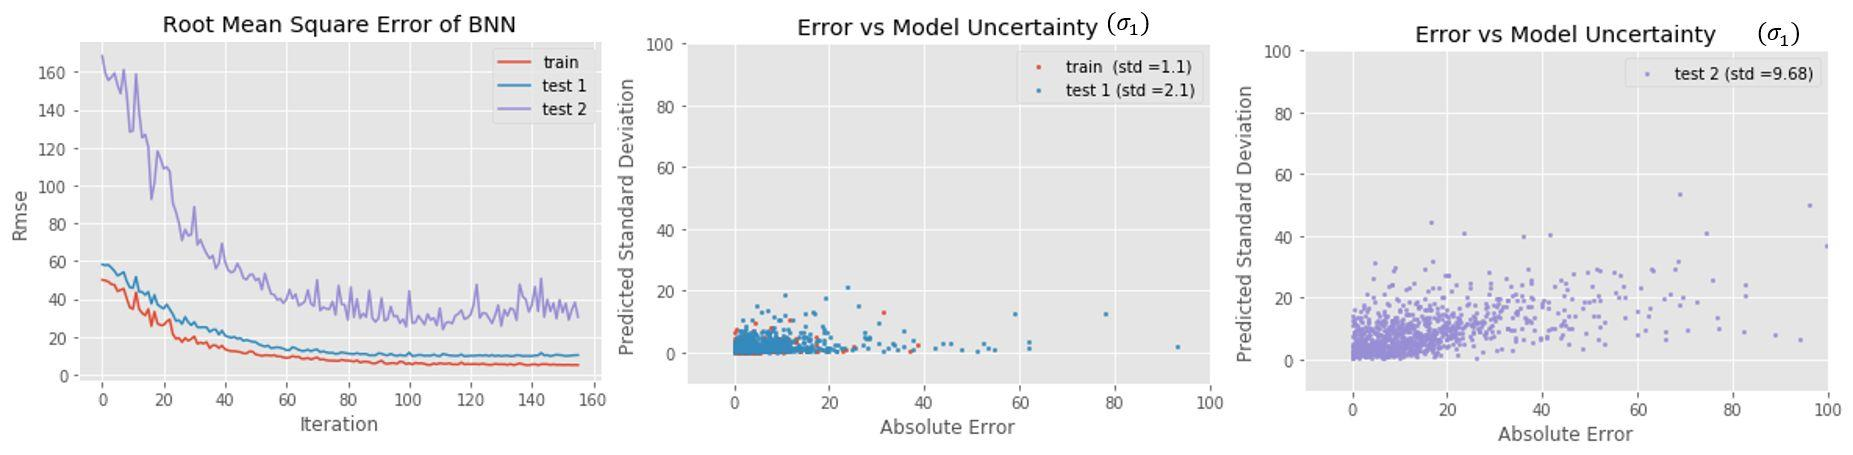Can you explain the relationship between absolute error and predicted standard deviation in these tests? Certainly. The 'Error vs Model Uncertainty' graphs depict a scatter plot where each point corresponds to a prediction. The x-axis marks the absolute error of these predictions, and the y-axis indicates the predicted standard deviation, which reflects model uncertainty. If a model is well-calibrated, we'd expect to see a correlation where higher errors correspond to higher predicted uncertainties. By examining these graphs, one can identify how well the model acknowledges its own limitations, i.e., its uncertainty estimates align with its actual errors. 